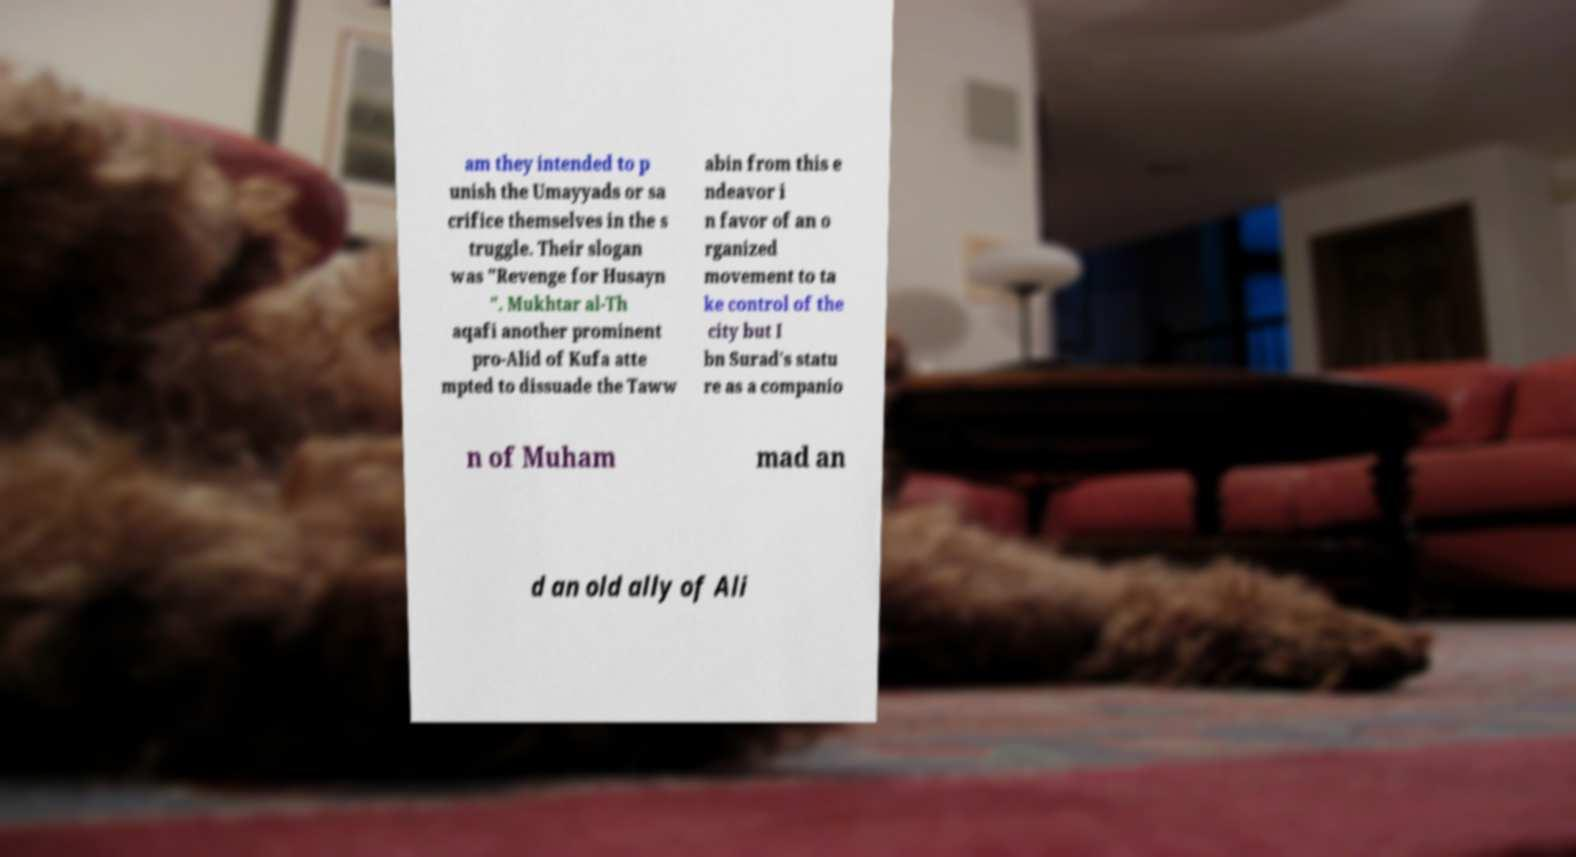There's text embedded in this image that I need extracted. Can you transcribe it verbatim? am they intended to p unish the Umayyads or sa crifice themselves in the s truggle. Their slogan was "Revenge for Husayn ". Mukhtar al-Th aqafi another prominent pro-Alid of Kufa atte mpted to dissuade the Taww abin from this e ndeavor i n favor of an o rganized movement to ta ke control of the city but I bn Surad's statu re as a companio n of Muham mad an d an old ally of Ali 